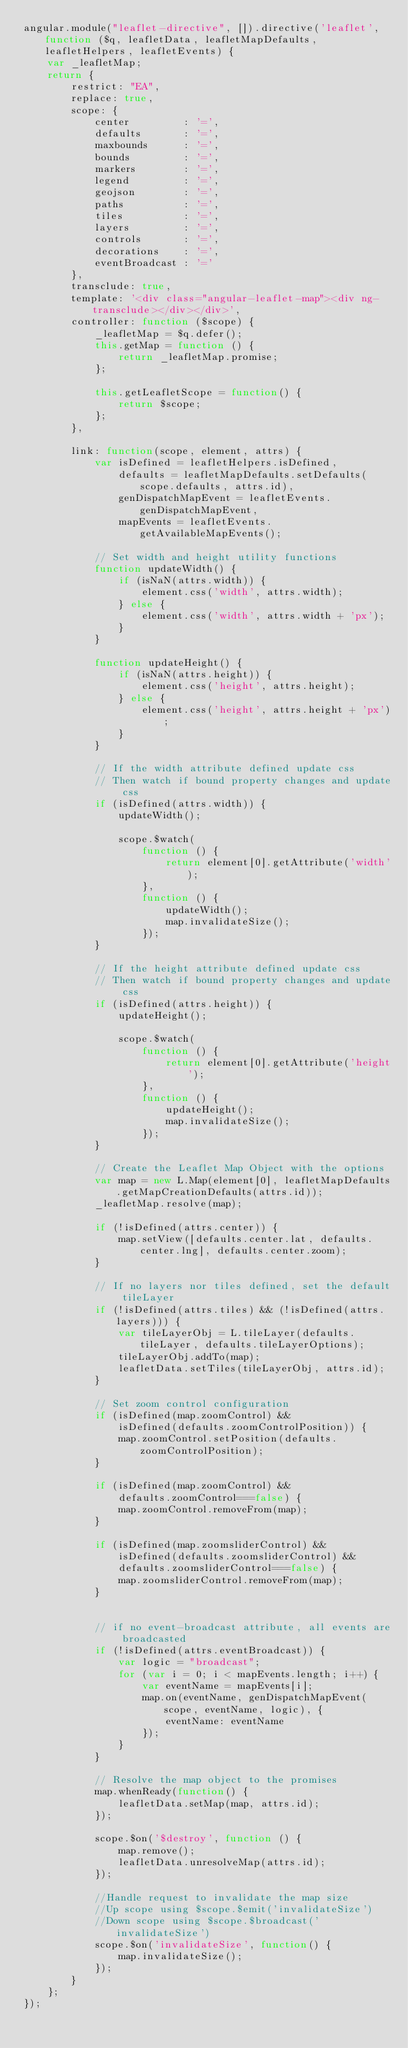<code> <loc_0><loc_0><loc_500><loc_500><_JavaScript_>angular.module("leaflet-directive", []).directive('leaflet', function ($q, leafletData, leafletMapDefaults, leafletHelpers, leafletEvents) {
    var _leafletMap;
    return {
        restrict: "EA",
        replace: true,
        scope: {
            center         : '=',
            defaults       : '=',
            maxbounds      : '=',
            bounds         : '=',
            markers        : '=',
            legend         : '=',
            geojson        : '=',
            paths          : '=',
            tiles          : '=',
            layers         : '=',
            controls       : '=',
            decorations    : '=',
            eventBroadcast : '='
        },
        transclude: true,
        template: '<div class="angular-leaflet-map"><div ng-transclude></div></div>',
        controller: function ($scope) {
            _leafletMap = $q.defer();
            this.getMap = function () {
                return _leafletMap.promise;
            };

            this.getLeafletScope = function() {
                return $scope;
            };
        },

        link: function(scope, element, attrs) {
            var isDefined = leafletHelpers.isDefined,
                defaults = leafletMapDefaults.setDefaults(scope.defaults, attrs.id),
                genDispatchMapEvent = leafletEvents.genDispatchMapEvent,
                mapEvents = leafletEvents.getAvailableMapEvents();

            // Set width and height utility functions
            function updateWidth() {
                if (isNaN(attrs.width)) {
                    element.css('width', attrs.width);
                } else {
                    element.css('width', attrs.width + 'px');
                }
            }

            function updateHeight() {
                if (isNaN(attrs.height)) {
                    element.css('height', attrs.height);
                } else {
                    element.css('height', attrs.height + 'px');
                }
            }

            // If the width attribute defined update css
            // Then watch if bound property changes and update css
            if (isDefined(attrs.width)) {
                updateWidth();

                scope.$watch(
                    function () {
                        return element[0].getAttribute('width');
                    },
                    function () {
                        updateWidth();
                        map.invalidateSize();
                    });
            }

            // If the height attribute defined update css
            // Then watch if bound property changes and update css
            if (isDefined(attrs.height)) {
                updateHeight();

                scope.$watch(
                    function () {
                        return element[0].getAttribute('height');
                    },
                    function () {
                        updateHeight();
                        map.invalidateSize();
                    });
            }

            // Create the Leaflet Map Object with the options
            var map = new L.Map(element[0], leafletMapDefaults.getMapCreationDefaults(attrs.id));
            _leafletMap.resolve(map);

            if (!isDefined(attrs.center)) {
                map.setView([defaults.center.lat, defaults.center.lng], defaults.center.zoom);
            }

            // If no layers nor tiles defined, set the default tileLayer
            if (!isDefined(attrs.tiles) && (!isDefined(attrs.layers))) {
                var tileLayerObj = L.tileLayer(defaults.tileLayer, defaults.tileLayerOptions);
                tileLayerObj.addTo(map);
                leafletData.setTiles(tileLayerObj, attrs.id);
            }

            // Set zoom control configuration
            if (isDefined(map.zoomControl) &&
                isDefined(defaults.zoomControlPosition)) {
                map.zoomControl.setPosition(defaults.zoomControlPosition);
            }

            if (isDefined(map.zoomControl) &&
                defaults.zoomControl===false) {
                map.zoomControl.removeFrom(map);
            }

            if (isDefined(map.zoomsliderControl) &&
                isDefined(defaults.zoomsliderControl) &&
                defaults.zoomsliderControl===false) {
                map.zoomsliderControl.removeFrom(map);
            }


            // if no event-broadcast attribute, all events are broadcasted
            if (!isDefined(attrs.eventBroadcast)) {
                var logic = "broadcast";
                for (var i = 0; i < mapEvents.length; i++) {
                    var eventName = mapEvents[i];
                    map.on(eventName, genDispatchMapEvent(scope, eventName, logic), {
                        eventName: eventName
                    });
                }
            }

            // Resolve the map object to the promises
            map.whenReady(function() {
                leafletData.setMap(map, attrs.id);
            });

            scope.$on('$destroy', function () {
                map.remove();
                leafletData.unresolveMap(attrs.id);
            });

            //Handle request to invalidate the map size
	        //Up scope using $scope.$emit('invalidateSize')
	        //Down scope using $scope.$broadcast('invalidateSize')
            scope.$on('invalidateSize', function() {
                map.invalidateSize();
            });
        }
    };
});
</code> 